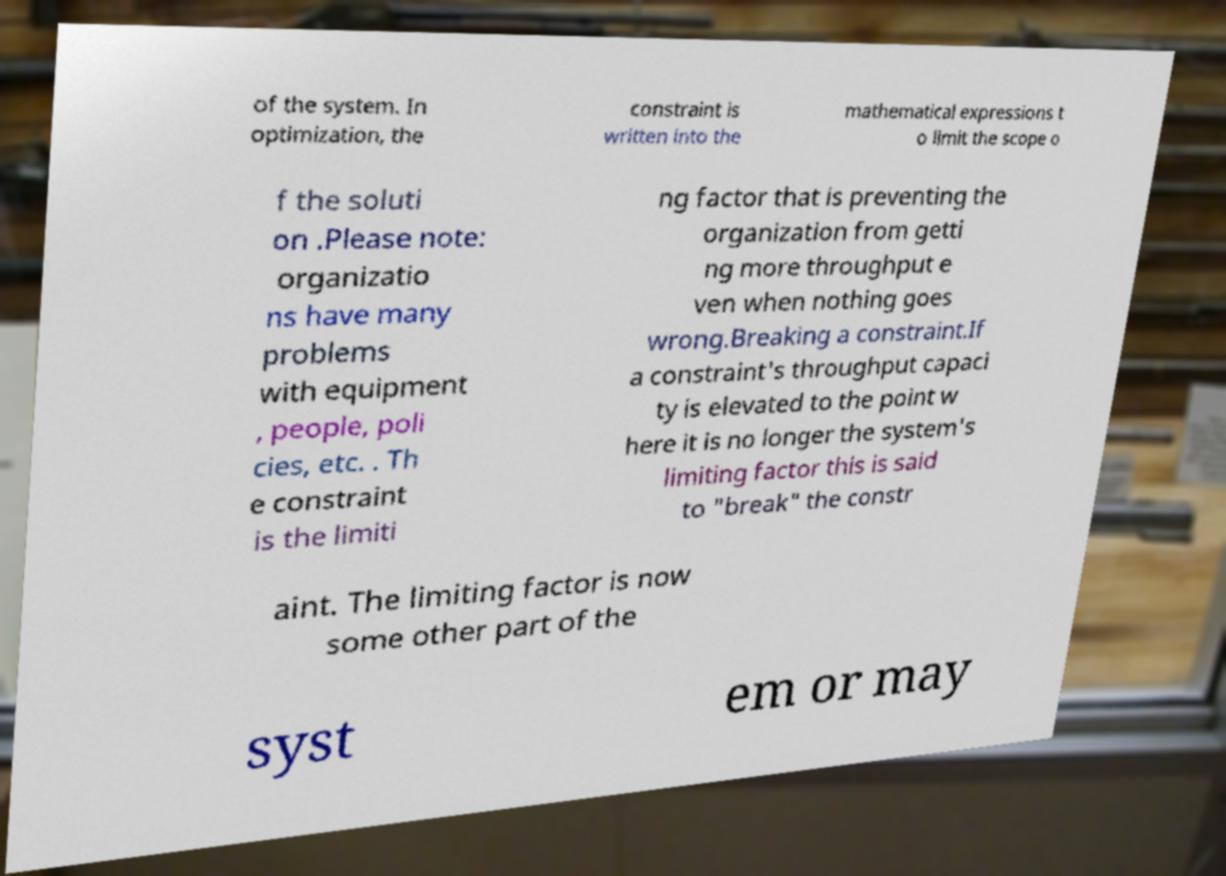Could you extract and type out the text from this image? of the system. In optimization, the constraint is written into the mathematical expressions t o limit the scope o f the soluti on .Please note: organizatio ns have many problems with equipment , people, poli cies, etc. . Th e constraint is the limiti ng factor that is preventing the organization from getti ng more throughput e ven when nothing goes wrong.Breaking a constraint.If a constraint's throughput capaci ty is elevated to the point w here it is no longer the system's limiting factor this is said to "break" the constr aint. The limiting factor is now some other part of the syst em or may 